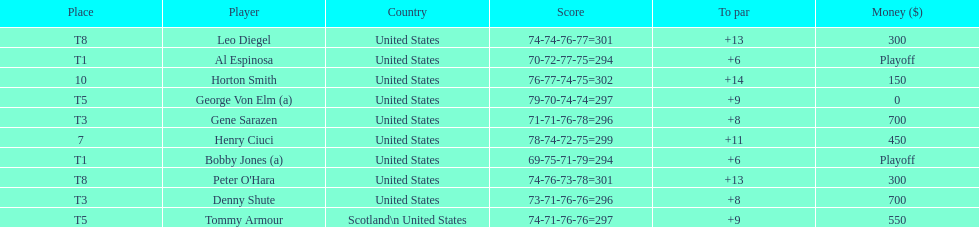Who finished next after bobby jones and al espinosa? Gene Sarazen, Denny Shute. 